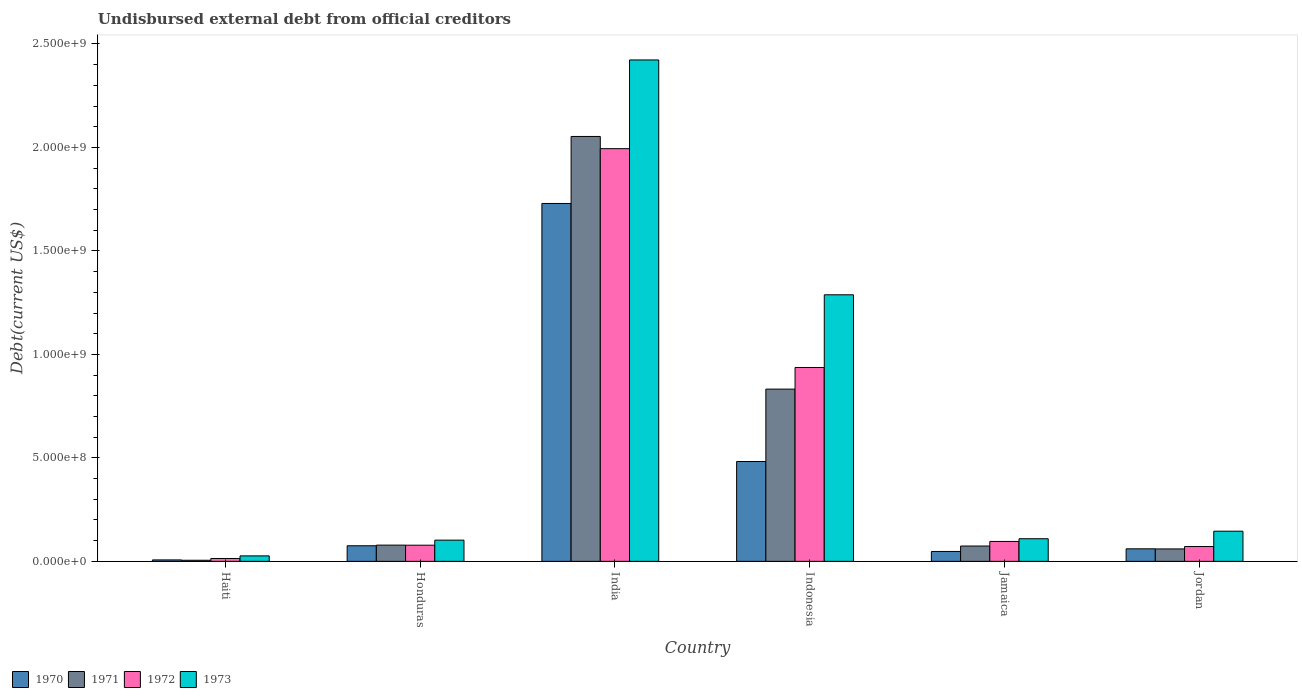Are the number of bars on each tick of the X-axis equal?
Provide a short and direct response. Yes. How many bars are there on the 1st tick from the left?
Keep it short and to the point. 4. What is the label of the 5th group of bars from the left?
Make the answer very short. Jamaica. What is the total debt in 1971 in Jordan?
Your response must be concise. 6.01e+07. Across all countries, what is the maximum total debt in 1973?
Give a very brief answer. 2.42e+09. Across all countries, what is the minimum total debt in 1970?
Make the answer very short. 6.96e+06. In which country was the total debt in 1971 minimum?
Offer a very short reply. Haiti. What is the total total debt in 1970 in the graph?
Provide a succinct answer. 2.40e+09. What is the difference between the total debt in 1970 in Honduras and that in India?
Provide a succinct answer. -1.65e+09. What is the difference between the total debt in 1972 in Haiti and the total debt in 1970 in Indonesia?
Make the answer very short. -4.69e+08. What is the average total debt in 1971 per country?
Offer a terse response. 5.17e+08. What is the difference between the total debt of/in 1971 and total debt of/in 1972 in Honduras?
Your response must be concise. 3.37e+05. What is the ratio of the total debt in 1970 in Haiti to that in Jamaica?
Your answer should be very brief. 0.15. Is the total debt in 1970 in Haiti less than that in Jamaica?
Keep it short and to the point. Yes. What is the difference between the highest and the second highest total debt in 1971?
Your response must be concise. -1.22e+09. What is the difference between the highest and the lowest total debt in 1970?
Offer a very short reply. 1.72e+09. In how many countries, is the total debt in 1971 greater than the average total debt in 1971 taken over all countries?
Keep it short and to the point. 2. Is it the case that in every country, the sum of the total debt in 1972 and total debt in 1971 is greater than the sum of total debt in 1973 and total debt in 1970?
Keep it short and to the point. No. What does the 1st bar from the right in India represents?
Your response must be concise. 1973. Is it the case that in every country, the sum of the total debt in 1972 and total debt in 1973 is greater than the total debt in 1971?
Provide a succinct answer. Yes. Are all the bars in the graph horizontal?
Give a very brief answer. No. How many countries are there in the graph?
Your answer should be compact. 6. Does the graph contain grids?
Your answer should be very brief. No. Where does the legend appear in the graph?
Give a very brief answer. Bottom left. How many legend labels are there?
Provide a succinct answer. 4. How are the legend labels stacked?
Keep it short and to the point. Horizontal. What is the title of the graph?
Your answer should be very brief. Undisbursed external debt from official creditors. What is the label or title of the X-axis?
Your response must be concise. Country. What is the label or title of the Y-axis?
Give a very brief answer. Debt(current US$). What is the Debt(current US$) in 1970 in Haiti?
Make the answer very short. 6.96e+06. What is the Debt(current US$) of 1971 in Haiti?
Keep it short and to the point. 5.35e+06. What is the Debt(current US$) in 1972 in Haiti?
Give a very brief answer. 1.39e+07. What is the Debt(current US$) of 1973 in Haiti?
Offer a terse response. 2.64e+07. What is the Debt(current US$) of 1970 in Honduras?
Your answer should be compact. 7.54e+07. What is the Debt(current US$) in 1971 in Honduras?
Your response must be concise. 7.85e+07. What is the Debt(current US$) of 1972 in Honduras?
Offer a terse response. 7.81e+07. What is the Debt(current US$) of 1973 in Honduras?
Offer a very short reply. 1.02e+08. What is the Debt(current US$) in 1970 in India?
Provide a short and direct response. 1.73e+09. What is the Debt(current US$) of 1971 in India?
Your answer should be very brief. 2.05e+09. What is the Debt(current US$) in 1972 in India?
Your response must be concise. 1.99e+09. What is the Debt(current US$) in 1973 in India?
Offer a terse response. 2.42e+09. What is the Debt(current US$) of 1970 in Indonesia?
Provide a short and direct response. 4.82e+08. What is the Debt(current US$) in 1971 in Indonesia?
Your answer should be compact. 8.32e+08. What is the Debt(current US$) of 1972 in Indonesia?
Your response must be concise. 9.37e+08. What is the Debt(current US$) of 1973 in Indonesia?
Keep it short and to the point. 1.29e+09. What is the Debt(current US$) in 1970 in Jamaica?
Your answer should be compact. 4.78e+07. What is the Debt(current US$) in 1971 in Jamaica?
Give a very brief answer. 7.41e+07. What is the Debt(current US$) of 1972 in Jamaica?
Make the answer very short. 9.62e+07. What is the Debt(current US$) of 1973 in Jamaica?
Make the answer very short. 1.09e+08. What is the Debt(current US$) of 1970 in Jordan?
Keep it short and to the point. 6.06e+07. What is the Debt(current US$) in 1971 in Jordan?
Provide a succinct answer. 6.01e+07. What is the Debt(current US$) of 1972 in Jordan?
Your answer should be compact. 7.16e+07. What is the Debt(current US$) in 1973 in Jordan?
Your response must be concise. 1.46e+08. Across all countries, what is the maximum Debt(current US$) in 1970?
Give a very brief answer. 1.73e+09. Across all countries, what is the maximum Debt(current US$) of 1971?
Give a very brief answer. 2.05e+09. Across all countries, what is the maximum Debt(current US$) in 1972?
Make the answer very short. 1.99e+09. Across all countries, what is the maximum Debt(current US$) in 1973?
Keep it short and to the point. 2.42e+09. Across all countries, what is the minimum Debt(current US$) of 1970?
Your response must be concise. 6.96e+06. Across all countries, what is the minimum Debt(current US$) of 1971?
Offer a very short reply. 5.35e+06. Across all countries, what is the minimum Debt(current US$) in 1972?
Your answer should be very brief. 1.39e+07. Across all countries, what is the minimum Debt(current US$) in 1973?
Give a very brief answer. 2.64e+07. What is the total Debt(current US$) of 1970 in the graph?
Your answer should be very brief. 2.40e+09. What is the total Debt(current US$) of 1971 in the graph?
Your answer should be compact. 3.10e+09. What is the total Debt(current US$) in 1972 in the graph?
Your answer should be very brief. 3.19e+09. What is the total Debt(current US$) in 1973 in the graph?
Your answer should be very brief. 4.09e+09. What is the difference between the Debt(current US$) of 1970 in Haiti and that in Honduras?
Ensure brevity in your answer.  -6.84e+07. What is the difference between the Debt(current US$) in 1971 in Haiti and that in Honduras?
Your answer should be compact. -7.31e+07. What is the difference between the Debt(current US$) of 1972 in Haiti and that in Honduras?
Your answer should be very brief. -6.42e+07. What is the difference between the Debt(current US$) in 1973 in Haiti and that in Honduras?
Give a very brief answer. -7.61e+07. What is the difference between the Debt(current US$) in 1970 in Haiti and that in India?
Provide a succinct answer. -1.72e+09. What is the difference between the Debt(current US$) of 1971 in Haiti and that in India?
Offer a terse response. -2.05e+09. What is the difference between the Debt(current US$) in 1972 in Haiti and that in India?
Keep it short and to the point. -1.98e+09. What is the difference between the Debt(current US$) of 1973 in Haiti and that in India?
Offer a terse response. -2.40e+09. What is the difference between the Debt(current US$) of 1970 in Haiti and that in Indonesia?
Ensure brevity in your answer.  -4.75e+08. What is the difference between the Debt(current US$) of 1971 in Haiti and that in Indonesia?
Give a very brief answer. -8.27e+08. What is the difference between the Debt(current US$) in 1972 in Haiti and that in Indonesia?
Ensure brevity in your answer.  -9.23e+08. What is the difference between the Debt(current US$) of 1973 in Haiti and that in Indonesia?
Your answer should be very brief. -1.26e+09. What is the difference between the Debt(current US$) of 1970 in Haiti and that in Jamaica?
Give a very brief answer. -4.08e+07. What is the difference between the Debt(current US$) in 1971 in Haiti and that in Jamaica?
Offer a very short reply. -6.88e+07. What is the difference between the Debt(current US$) in 1972 in Haiti and that in Jamaica?
Make the answer very short. -8.23e+07. What is the difference between the Debt(current US$) of 1973 in Haiti and that in Jamaica?
Provide a succinct answer. -8.29e+07. What is the difference between the Debt(current US$) of 1970 in Haiti and that in Jordan?
Your answer should be compact. -5.36e+07. What is the difference between the Debt(current US$) of 1971 in Haiti and that in Jordan?
Offer a very short reply. -5.47e+07. What is the difference between the Debt(current US$) in 1972 in Haiti and that in Jordan?
Provide a succinct answer. -5.77e+07. What is the difference between the Debt(current US$) of 1973 in Haiti and that in Jordan?
Provide a short and direct response. -1.19e+08. What is the difference between the Debt(current US$) of 1970 in Honduras and that in India?
Keep it short and to the point. -1.65e+09. What is the difference between the Debt(current US$) in 1971 in Honduras and that in India?
Make the answer very short. -1.97e+09. What is the difference between the Debt(current US$) in 1972 in Honduras and that in India?
Your response must be concise. -1.92e+09. What is the difference between the Debt(current US$) in 1973 in Honduras and that in India?
Keep it short and to the point. -2.32e+09. What is the difference between the Debt(current US$) in 1970 in Honduras and that in Indonesia?
Keep it short and to the point. -4.07e+08. What is the difference between the Debt(current US$) in 1971 in Honduras and that in Indonesia?
Your answer should be very brief. -7.54e+08. What is the difference between the Debt(current US$) of 1972 in Honduras and that in Indonesia?
Your response must be concise. -8.59e+08. What is the difference between the Debt(current US$) of 1973 in Honduras and that in Indonesia?
Offer a terse response. -1.19e+09. What is the difference between the Debt(current US$) in 1970 in Honduras and that in Jamaica?
Your response must be concise. 2.76e+07. What is the difference between the Debt(current US$) of 1971 in Honduras and that in Jamaica?
Give a very brief answer. 4.34e+06. What is the difference between the Debt(current US$) in 1972 in Honduras and that in Jamaica?
Offer a very short reply. -1.81e+07. What is the difference between the Debt(current US$) of 1973 in Honduras and that in Jamaica?
Ensure brevity in your answer.  -6.85e+06. What is the difference between the Debt(current US$) in 1970 in Honduras and that in Jordan?
Provide a short and direct response. 1.48e+07. What is the difference between the Debt(current US$) in 1971 in Honduras and that in Jordan?
Offer a very short reply. 1.84e+07. What is the difference between the Debt(current US$) of 1972 in Honduras and that in Jordan?
Give a very brief answer. 6.52e+06. What is the difference between the Debt(current US$) of 1973 in Honduras and that in Jordan?
Make the answer very short. -4.32e+07. What is the difference between the Debt(current US$) of 1970 in India and that in Indonesia?
Give a very brief answer. 1.25e+09. What is the difference between the Debt(current US$) in 1971 in India and that in Indonesia?
Keep it short and to the point. 1.22e+09. What is the difference between the Debt(current US$) of 1972 in India and that in Indonesia?
Offer a terse response. 1.06e+09. What is the difference between the Debt(current US$) in 1973 in India and that in Indonesia?
Your answer should be compact. 1.13e+09. What is the difference between the Debt(current US$) of 1970 in India and that in Jamaica?
Provide a short and direct response. 1.68e+09. What is the difference between the Debt(current US$) of 1971 in India and that in Jamaica?
Offer a very short reply. 1.98e+09. What is the difference between the Debt(current US$) of 1972 in India and that in Jamaica?
Make the answer very short. 1.90e+09. What is the difference between the Debt(current US$) of 1973 in India and that in Jamaica?
Your answer should be compact. 2.31e+09. What is the difference between the Debt(current US$) of 1970 in India and that in Jordan?
Ensure brevity in your answer.  1.67e+09. What is the difference between the Debt(current US$) in 1971 in India and that in Jordan?
Your answer should be very brief. 1.99e+09. What is the difference between the Debt(current US$) in 1972 in India and that in Jordan?
Offer a very short reply. 1.92e+09. What is the difference between the Debt(current US$) of 1973 in India and that in Jordan?
Give a very brief answer. 2.28e+09. What is the difference between the Debt(current US$) in 1970 in Indonesia and that in Jamaica?
Offer a terse response. 4.35e+08. What is the difference between the Debt(current US$) of 1971 in Indonesia and that in Jamaica?
Make the answer very short. 7.58e+08. What is the difference between the Debt(current US$) of 1972 in Indonesia and that in Jamaica?
Ensure brevity in your answer.  8.41e+08. What is the difference between the Debt(current US$) in 1973 in Indonesia and that in Jamaica?
Ensure brevity in your answer.  1.18e+09. What is the difference between the Debt(current US$) in 1970 in Indonesia and that in Jordan?
Keep it short and to the point. 4.22e+08. What is the difference between the Debt(current US$) in 1971 in Indonesia and that in Jordan?
Your answer should be very brief. 7.72e+08. What is the difference between the Debt(current US$) of 1972 in Indonesia and that in Jordan?
Your response must be concise. 8.65e+08. What is the difference between the Debt(current US$) in 1973 in Indonesia and that in Jordan?
Offer a very short reply. 1.14e+09. What is the difference between the Debt(current US$) in 1970 in Jamaica and that in Jordan?
Give a very brief answer. -1.28e+07. What is the difference between the Debt(current US$) of 1971 in Jamaica and that in Jordan?
Give a very brief answer. 1.40e+07. What is the difference between the Debt(current US$) in 1972 in Jamaica and that in Jordan?
Provide a short and direct response. 2.46e+07. What is the difference between the Debt(current US$) of 1973 in Jamaica and that in Jordan?
Provide a short and direct response. -3.64e+07. What is the difference between the Debt(current US$) in 1970 in Haiti and the Debt(current US$) in 1971 in Honduras?
Keep it short and to the point. -7.15e+07. What is the difference between the Debt(current US$) of 1970 in Haiti and the Debt(current US$) of 1972 in Honduras?
Make the answer very short. -7.12e+07. What is the difference between the Debt(current US$) in 1970 in Haiti and the Debt(current US$) in 1973 in Honduras?
Offer a very short reply. -9.55e+07. What is the difference between the Debt(current US$) of 1971 in Haiti and the Debt(current US$) of 1972 in Honduras?
Make the answer very short. -7.28e+07. What is the difference between the Debt(current US$) of 1971 in Haiti and the Debt(current US$) of 1973 in Honduras?
Offer a terse response. -9.71e+07. What is the difference between the Debt(current US$) of 1972 in Haiti and the Debt(current US$) of 1973 in Honduras?
Provide a succinct answer. -8.86e+07. What is the difference between the Debt(current US$) of 1970 in Haiti and the Debt(current US$) of 1971 in India?
Keep it short and to the point. -2.05e+09. What is the difference between the Debt(current US$) of 1970 in Haiti and the Debt(current US$) of 1972 in India?
Keep it short and to the point. -1.99e+09. What is the difference between the Debt(current US$) in 1970 in Haiti and the Debt(current US$) in 1973 in India?
Offer a terse response. -2.42e+09. What is the difference between the Debt(current US$) in 1971 in Haiti and the Debt(current US$) in 1972 in India?
Keep it short and to the point. -1.99e+09. What is the difference between the Debt(current US$) in 1971 in Haiti and the Debt(current US$) in 1973 in India?
Make the answer very short. -2.42e+09. What is the difference between the Debt(current US$) in 1972 in Haiti and the Debt(current US$) in 1973 in India?
Give a very brief answer. -2.41e+09. What is the difference between the Debt(current US$) in 1970 in Haiti and the Debt(current US$) in 1971 in Indonesia?
Provide a succinct answer. -8.25e+08. What is the difference between the Debt(current US$) of 1970 in Haiti and the Debt(current US$) of 1972 in Indonesia?
Provide a short and direct response. -9.30e+08. What is the difference between the Debt(current US$) in 1970 in Haiti and the Debt(current US$) in 1973 in Indonesia?
Offer a terse response. -1.28e+09. What is the difference between the Debt(current US$) of 1971 in Haiti and the Debt(current US$) of 1972 in Indonesia?
Make the answer very short. -9.31e+08. What is the difference between the Debt(current US$) in 1971 in Haiti and the Debt(current US$) in 1973 in Indonesia?
Make the answer very short. -1.28e+09. What is the difference between the Debt(current US$) of 1972 in Haiti and the Debt(current US$) of 1973 in Indonesia?
Provide a short and direct response. -1.27e+09. What is the difference between the Debt(current US$) of 1970 in Haiti and the Debt(current US$) of 1971 in Jamaica?
Provide a short and direct response. -6.72e+07. What is the difference between the Debt(current US$) in 1970 in Haiti and the Debt(current US$) in 1972 in Jamaica?
Your response must be concise. -8.92e+07. What is the difference between the Debt(current US$) of 1970 in Haiti and the Debt(current US$) of 1973 in Jamaica?
Offer a very short reply. -1.02e+08. What is the difference between the Debt(current US$) in 1971 in Haiti and the Debt(current US$) in 1972 in Jamaica?
Your answer should be very brief. -9.08e+07. What is the difference between the Debt(current US$) in 1971 in Haiti and the Debt(current US$) in 1973 in Jamaica?
Provide a succinct answer. -1.04e+08. What is the difference between the Debt(current US$) in 1972 in Haiti and the Debt(current US$) in 1973 in Jamaica?
Your response must be concise. -9.55e+07. What is the difference between the Debt(current US$) of 1970 in Haiti and the Debt(current US$) of 1971 in Jordan?
Give a very brief answer. -5.31e+07. What is the difference between the Debt(current US$) of 1970 in Haiti and the Debt(current US$) of 1972 in Jordan?
Your response must be concise. -6.46e+07. What is the difference between the Debt(current US$) of 1970 in Haiti and the Debt(current US$) of 1973 in Jordan?
Offer a very short reply. -1.39e+08. What is the difference between the Debt(current US$) of 1971 in Haiti and the Debt(current US$) of 1972 in Jordan?
Provide a succinct answer. -6.63e+07. What is the difference between the Debt(current US$) of 1971 in Haiti and the Debt(current US$) of 1973 in Jordan?
Offer a very short reply. -1.40e+08. What is the difference between the Debt(current US$) in 1972 in Haiti and the Debt(current US$) in 1973 in Jordan?
Provide a succinct answer. -1.32e+08. What is the difference between the Debt(current US$) of 1970 in Honduras and the Debt(current US$) of 1971 in India?
Give a very brief answer. -1.98e+09. What is the difference between the Debt(current US$) in 1970 in Honduras and the Debt(current US$) in 1972 in India?
Offer a terse response. -1.92e+09. What is the difference between the Debt(current US$) in 1970 in Honduras and the Debt(current US$) in 1973 in India?
Give a very brief answer. -2.35e+09. What is the difference between the Debt(current US$) of 1971 in Honduras and the Debt(current US$) of 1972 in India?
Provide a succinct answer. -1.92e+09. What is the difference between the Debt(current US$) of 1971 in Honduras and the Debt(current US$) of 1973 in India?
Keep it short and to the point. -2.34e+09. What is the difference between the Debt(current US$) in 1972 in Honduras and the Debt(current US$) in 1973 in India?
Offer a terse response. -2.34e+09. What is the difference between the Debt(current US$) of 1970 in Honduras and the Debt(current US$) of 1971 in Indonesia?
Your response must be concise. -7.57e+08. What is the difference between the Debt(current US$) of 1970 in Honduras and the Debt(current US$) of 1972 in Indonesia?
Provide a succinct answer. -8.61e+08. What is the difference between the Debt(current US$) of 1970 in Honduras and the Debt(current US$) of 1973 in Indonesia?
Your response must be concise. -1.21e+09. What is the difference between the Debt(current US$) in 1971 in Honduras and the Debt(current US$) in 1972 in Indonesia?
Provide a succinct answer. -8.58e+08. What is the difference between the Debt(current US$) in 1971 in Honduras and the Debt(current US$) in 1973 in Indonesia?
Keep it short and to the point. -1.21e+09. What is the difference between the Debt(current US$) in 1972 in Honduras and the Debt(current US$) in 1973 in Indonesia?
Provide a succinct answer. -1.21e+09. What is the difference between the Debt(current US$) of 1970 in Honduras and the Debt(current US$) of 1971 in Jamaica?
Your answer should be compact. 1.28e+06. What is the difference between the Debt(current US$) of 1970 in Honduras and the Debt(current US$) of 1972 in Jamaica?
Ensure brevity in your answer.  -2.08e+07. What is the difference between the Debt(current US$) in 1970 in Honduras and the Debt(current US$) in 1973 in Jamaica?
Provide a succinct answer. -3.39e+07. What is the difference between the Debt(current US$) of 1971 in Honduras and the Debt(current US$) of 1972 in Jamaica?
Offer a very short reply. -1.77e+07. What is the difference between the Debt(current US$) in 1971 in Honduras and the Debt(current US$) in 1973 in Jamaica?
Ensure brevity in your answer.  -3.09e+07. What is the difference between the Debt(current US$) of 1972 in Honduras and the Debt(current US$) of 1973 in Jamaica?
Your answer should be compact. -3.12e+07. What is the difference between the Debt(current US$) of 1970 in Honduras and the Debt(current US$) of 1971 in Jordan?
Keep it short and to the point. 1.53e+07. What is the difference between the Debt(current US$) in 1970 in Honduras and the Debt(current US$) in 1972 in Jordan?
Provide a short and direct response. 3.79e+06. What is the difference between the Debt(current US$) in 1970 in Honduras and the Debt(current US$) in 1973 in Jordan?
Keep it short and to the point. -7.03e+07. What is the difference between the Debt(current US$) of 1971 in Honduras and the Debt(current US$) of 1972 in Jordan?
Keep it short and to the point. 6.85e+06. What is the difference between the Debt(current US$) of 1971 in Honduras and the Debt(current US$) of 1973 in Jordan?
Offer a very short reply. -6.73e+07. What is the difference between the Debt(current US$) in 1972 in Honduras and the Debt(current US$) in 1973 in Jordan?
Make the answer very short. -6.76e+07. What is the difference between the Debt(current US$) in 1970 in India and the Debt(current US$) in 1971 in Indonesia?
Provide a short and direct response. 8.97e+08. What is the difference between the Debt(current US$) of 1970 in India and the Debt(current US$) of 1972 in Indonesia?
Your answer should be compact. 7.93e+08. What is the difference between the Debt(current US$) in 1970 in India and the Debt(current US$) in 1973 in Indonesia?
Your answer should be compact. 4.41e+08. What is the difference between the Debt(current US$) of 1971 in India and the Debt(current US$) of 1972 in Indonesia?
Offer a very short reply. 1.12e+09. What is the difference between the Debt(current US$) of 1971 in India and the Debt(current US$) of 1973 in Indonesia?
Make the answer very short. 7.65e+08. What is the difference between the Debt(current US$) of 1972 in India and the Debt(current US$) of 1973 in Indonesia?
Make the answer very short. 7.06e+08. What is the difference between the Debt(current US$) of 1970 in India and the Debt(current US$) of 1971 in Jamaica?
Ensure brevity in your answer.  1.66e+09. What is the difference between the Debt(current US$) in 1970 in India and the Debt(current US$) in 1972 in Jamaica?
Offer a terse response. 1.63e+09. What is the difference between the Debt(current US$) of 1970 in India and the Debt(current US$) of 1973 in Jamaica?
Keep it short and to the point. 1.62e+09. What is the difference between the Debt(current US$) of 1971 in India and the Debt(current US$) of 1972 in Jamaica?
Offer a very short reply. 1.96e+09. What is the difference between the Debt(current US$) in 1971 in India and the Debt(current US$) in 1973 in Jamaica?
Your response must be concise. 1.94e+09. What is the difference between the Debt(current US$) of 1972 in India and the Debt(current US$) of 1973 in Jamaica?
Ensure brevity in your answer.  1.88e+09. What is the difference between the Debt(current US$) of 1970 in India and the Debt(current US$) of 1971 in Jordan?
Your answer should be very brief. 1.67e+09. What is the difference between the Debt(current US$) of 1970 in India and the Debt(current US$) of 1972 in Jordan?
Offer a very short reply. 1.66e+09. What is the difference between the Debt(current US$) of 1970 in India and the Debt(current US$) of 1973 in Jordan?
Your response must be concise. 1.58e+09. What is the difference between the Debt(current US$) in 1971 in India and the Debt(current US$) in 1972 in Jordan?
Keep it short and to the point. 1.98e+09. What is the difference between the Debt(current US$) in 1971 in India and the Debt(current US$) in 1973 in Jordan?
Provide a succinct answer. 1.91e+09. What is the difference between the Debt(current US$) of 1972 in India and the Debt(current US$) of 1973 in Jordan?
Your response must be concise. 1.85e+09. What is the difference between the Debt(current US$) in 1970 in Indonesia and the Debt(current US$) in 1971 in Jamaica?
Your response must be concise. 4.08e+08. What is the difference between the Debt(current US$) in 1970 in Indonesia and the Debt(current US$) in 1972 in Jamaica?
Your answer should be very brief. 3.86e+08. What is the difference between the Debt(current US$) in 1970 in Indonesia and the Debt(current US$) in 1973 in Jamaica?
Your answer should be very brief. 3.73e+08. What is the difference between the Debt(current US$) of 1971 in Indonesia and the Debt(current US$) of 1972 in Jamaica?
Make the answer very short. 7.36e+08. What is the difference between the Debt(current US$) in 1971 in Indonesia and the Debt(current US$) in 1973 in Jamaica?
Offer a very short reply. 7.23e+08. What is the difference between the Debt(current US$) of 1972 in Indonesia and the Debt(current US$) of 1973 in Jamaica?
Your answer should be compact. 8.27e+08. What is the difference between the Debt(current US$) in 1970 in Indonesia and the Debt(current US$) in 1971 in Jordan?
Ensure brevity in your answer.  4.22e+08. What is the difference between the Debt(current US$) in 1970 in Indonesia and the Debt(current US$) in 1972 in Jordan?
Your answer should be very brief. 4.11e+08. What is the difference between the Debt(current US$) in 1970 in Indonesia and the Debt(current US$) in 1973 in Jordan?
Make the answer very short. 3.37e+08. What is the difference between the Debt(current US$) of 1971 in Indonesia and the Debt(current US$) of 1972 in Jordan?
Keep it short and to the point. 7.61e+08. What is the difference between the Debt(current US$) in 1971 in Indonesia and the Debt(current US$) in 1973 in Jordan?
Your answer should be very brief. 6.87e+08. What is the difference between the Debt(current US$) in 1972 in Indonesia and the Debt(current US$) in 1973 in Jordan?
Make the answer very short. 7.91e+08. What is the difference between the Debt(current US$) in 1970 in Jamaica and the Debt(current US$) in 1971 in Jordan?
Ensure brevity in your answer.  -1.23e+07. What is the difference between the Debt(current US$) of 1970 in Jamaica and the Debt(current US$) of 1972 in Jordan?
Offer a terse response. -2.38e+07. What is the difference between the Debt(current US$) of 1970 in Jamaica and the Debt(current US$) of 1973 in Jordan?
Offer a terse response. -9.79e+07. What is the difference between the Debt(current US$) of 1971 in Jamaica and the Debt(current US$) of 1972 in Jordan?
Your response must be concise. 2.51e+06. What is the difference between the Debt(current US$) of 1971 in Jamaica and the Debt(current US$) of 1973 in Jordan?
Provide a short and direct response. -7.16e+07. What is the difference between the Debt(current US$) in 1972 in Jamaica and the Debt(current US$) in 1973 in Jordan?
Give a very brief answer. -4.95e+07. What is the average Debt(current US$) in 1970 per country?
Provide a short and direct response. 4.00e+08. What is the average Debt(current US$) of 1971 per country?
Ensure brevity in your answer.  5.17e+08. What is the average Debt(current US$) in 1972 per country?
Ensure brevity in your answer.  5.32e+08. What is the average Debt(current US$) of 1973 per country?
Ensure brevity in your answer.  6.82e+08. What is the difference between the Debt(current US$) of 1970 and Debt(current US$) of 1971 in Haiti?
Ensure brevity in your answer.  1.61e+06. What is the difference between the Debt(current US$) of 1970 and Debt(current US$) of 1972 in Haiti?
Provide a short and direct response. -6.92e+06. What is the difference between the Debt(current US$) of 1970 and Debt(current US$) of 1973 in Haiti?
Provide a succinct answer. -1.95e+07. What is the difference between the Debt(current US$) in 1971 and Debt(current US$) in 1972 in Haiti?
Offer a very short reply. -8.53e+06. What is the difference between the Debt(current US$) of 1971 and Debt(current US$) of 1973 in Haiti?
Provide a short and direct response. -2.11e+07. What is the difference between the Debt(current US$) of 1972 and Debt(current US$) of 1973 in Haiti?
Offer a terse response. -1.25e+07. What is the difference between the Debt(current US$) of 1970 and Debt(current US$) of 1971 in Honduras?
Ensure brevity in your answer.  -3.06e+06. What is the difference between the Debt(current US$) of 1970 and Debt(current US$) of 1972 in Honduras?
Provide a succinct answer. -2.72e+06. What is the difference between the Debt(current US$) in 1970 and Debt(current US$) in 1973 in Honduras?
Make the answer very short. -2.71e+07. What is the difference between the Debt(current US$) in 1971 and Debt(current US$) in 1972 in Honduras?
Offer a terse response. 3.37e+05. What is the difference between the Debt(current US$) of 1971 and Debt(current US$) of 1973 in Honduras?
Give a very brief answer. -2.40e+07. What is the difference between the Debt(current US$) of 1972 and Debt(current US$) of 1973 in Honduras?
Provide a short and direct response. -2.44e+07. What is the difference between the Debt(current US$) in 1970 and Debt(current US$) in 1971 in India?
Your answer should be very brief. -3.24e+08. What is the difference between the Debt(current US$) of 1970 and Debt(current US$) of 1972 in India?
Offer a very short reply. -2.65e+08. What is the difference between the Debt(current US$) of 1970 and Debt(current US$) of 1973 in India?
Your answer should be very brief. -6.94e+08. What is the difference between the Debt(current US$) of 1971 and Debt(current US$) of 1972 in India?
Provide a succinct answer. 5.89e+07. What is the difference between the Debt(current US$) in 1971 and Debt(current US$) in 1973 in India?
Your answer should be compact. -3.70e+08. What is the difference between the Debt(current US$) in 1972 and Debt(current US$) in 1973 in India?
Keep it short and to the point. -4.29e+08. What is the difference between the Debt(current US$) in 1970 and Debt(current US$) in 1971 in Indonesia?
Keep it short and to the point. -3.50e+08. What is the difference between the Debt(current US$) of 1970 and Debt(current US$) of 1972 in Indonesia?
Give a very brief answer. -4.54e+08. What is the difference between the Debt(current US$) of 1970 and Debt(current US$) of 1973 in Indonesia?
Offer a terse response. -8.06e+08. What is the difference between the Debt(current US$) of 1971 and Debt(current US$) of 1972 in Indonesia?
Your response must be concise. -1.05e+08. What is the difference between the Debt(current US$) in 1971 and Debt(current US$) in 1973 in Indonesia?
Make the answer very short. -4.56e+08. What is the difference between the Debt(current US$) in 1972 and Debt(current US$) in 1973 in Indonesia?
Offer a terse response. -3.51e+08. What is the difference between the Debt(current US$) of 1970 and Debt(current US$) of 1971 in Jamaica?
Your answer should be very brief. -2.63e+07. What is the difference between the Debt(current US$) of 1970 and Debt(current US$) of 1972 in Jamaica?
Your answer should be very brief. -4.84e+07. What is the difference between the Debt(current US$) in 1970 and Debt(current US$) in 1973 in Jamaica?
Offer a terse response. -6.15e+07. What is the difference between the Debt(current US$) in 1971 and Debt(current US$) in 1972 in Jamaica?
Ensure brevity in your answer.  -2.21e+07. What is the difference between the Debt(current US$) of 1971 and Debt(current US$) of 1973 in Jamaica?
Your response must be concise. -3.52e+07. What is the difference between the Debt(current US$) of 1972 and Debt(current US$) of 1973 in Jamaica?
Ensure brevity in your answer.  -1.32e+07. What is the difference between the Debt(current US$) of 1970 and Debt(current US$) of 1971 in Jordan?
Give a very brief answer. 5.19e+05. What is the difference between the Debt(current US$) of 1970 and Debt(current US$) of 1972 in Jordan?
Provide a succinct answer. -1.10e+07. What is the difference between the Debt(current US$) in 1970 and Debt(current US$) in 1973 in Jordan?
Offer a terse response. -8.51e+07. What is the difference between the Debt(current US$) in 1971 and Debt(current US$) in 1972 in Jordan?
Your response must be concise. -1.15e+07. What is the difference between the Debt(current US$) of 1971 and Debt(current US$) of 1973 in Jordan?
Keep it short and to the point. -8.57e+07. What is the difference between the Debt(current US$) in 1972 and Debt(current US$) in 1973 in Jordan?
Keep it short and to the point. -7.41e+07. What is the ratio of the Debt(current US$) of 1970 in Haiti to that in Honduras?
Offer a terse response. 0.09. What is the ratio of the Debt(current US$) in 1971 in Haiti to that in Honduras?
Provide a succinct answer. 0.07. What is the ratio of the Debt(current US$) in 1972 in Haiti to that in Honduras?
Give a very brief answer. 0.18. What is the ratio of the Debt(current US$) of 1973 in Haiti to that in Honduras?
Provide a succinct answer. 0.26. What is the ratio of the Debt(current US$) in 1970 in Haiti to that in India?
Ensure brevity in your answer.  0. What is the ratio of the Debt(current US$) of 1971 in Haiti to that in India?
Make the answer very short. 0. What is the ratio of the Debt(current US$) in 1972 in Haiti to that in India?
Provide a short and direct response. 0.01. What is the ratio of the Debt(current US$) in 1973 in Haiti to that in India?
Make the answer very short. 0.01. What is the ratio of the Debt(current US$) of 1970 in Haiti to that in Indonesia?
Provide a succinct answer. 0.01. What is the ratio of the Debt(current US$) in 1971 in Haiti to that in Indonesia?
Ensure brevity in your answer.  0.01. What is the ratio of the Debt(current US$) of 1972 in Haiti to that in Indonesia?
Provide a succinct answer. 0.01. What is the ratio of the Debt(current US$) in 1973 in Haiti to that in Indonesia?
Offer a very short reply. 0.02. What is the ratio of the Debt(current US$) in 1970 in Haiti to that in Jamaica?
Your answer should be very brief. 0.15. What is the ratio of the Debt(current US$) in 1971 in Haiti to that in Jamaica?
Keep it short and to the point. 0.07. What is the ratio of the Debt(current US$) in 1972 in Haiti to that in Jamaica?
Your answer should be very brief. 0.14. What is the ratio of the Debt(current US$) in 1973 in Haiti to that in Jamaica?
Your response must be concise. 0.24. What is the ratio of the Debt(current US$) of 1970 in Haiti to that in Jordan?
Your answer should be very brief. 0.11. What is the ratio of the Debt(current US$) of 1971 in Haiti to that in Jordan?
Your answer should be compact. 0.09. What is the ratio of the Debt(current US$) in 1972 in Haiti to that in Jordan?
Provide a short and direct response. 0.19. What is the ratio of the Debt(current US$) in 1973 in Haiti to that in Jordan?
Your answer should be very brief. 0.18. What is the ratio of the Debt(current US$) of 1970 in Honduras to that in India?
Your answer should be very brief. 0.04. What is the ratio of the Debt(current US$) of 1971 in Honduras to that in India?
Offer a terse response. 0.04. What is the ratio of the Debt(current US$) of 1972 in Honduras to that in India?
Offer a very short reply. 0.04. What is the ratio of the Debt(current US$) of 1973 in Honduras to that in India?
Give a very brief answer. 0.04. What is the ratio of the Debt(current US$) in 1970 in Honduras to that in Indonesia?
Provide a succinct answer. 0.16. What is the ratio of the Debt(current US$) in 1971 in Honduras to that in Indonesia?
Offer a terse response. 0.09. What is the ratio of the Debt(current US$) of 1972 in Honduras to that in Indonesia?
Make the answer very short. 0.08. What is the ratio of the Debt(current US$) in 1973 in Honduras to that in Indonesia?
Offer a terse response. 0.08. What is the ratio of the Debt(current US$) in 1970 in Honduras to that in Jamaica?
Your answer should be very brief. 1.58. What is the ratio of the Debt(current US$) in 1971 in Honduras to that in Jamaica?
Ensure brevity in your answer.  1.06. What is the ratio of the Debt(current US$) in 1972 in Honduras to that in Jamaica?
Offer a very short reply. 0.81. What is the ratio of the Debt(current US$) of 1973 in Honduras to that in Jamaica?
Your response must be concise. 0.94. What is the ratio of the Debt(current US$) in 1970 in Honduras to that in Jordan?
Offer a terse response. 1.24. What is the ratio of the Debt(current US$) in 1971 in Honduras to that in Jordan?
Your answer should be very brief. 1.31. What is the ratio of the Debt(current US$) in 1972 in Honduras to that in Jordan?
Your answer should be compact. 1.09. What is the ratio of the Debt(current US$) in 1973 in Honduras to that in Jordan?
Give a very brief answer. 0.7. What is the ratio of the Debt(current US$) in 1970 in India to that in Indonesia?
Offer a very short reply. 3.58. What is the ratio of the Debt(current US$) in 1971 in India to that in Indonesia?
Your answer should be compact. 2.47. What is the ratio of the Debt(current US$) of 1972 in India to that in Indonesia?
Provide a short and direct response. 2.13. What is the ratio of the Debt(current US$) in 1973 in India to that in Indonesia?
Provide a succinct answer. 1.88. What is the ratio of the Debt(current US$) in 1970 in India to that in Jamaica?
Ensure brevity in your answer.  36.18. What is the ratio of the Debt(current US$) in 1971 in India to that in Jamaica?
Provide a succinct answer. 27.7. What is the ratio of the Debt(current US$) of 1972 in India to that in Jamaica?
Make the answer very short. 20.73. What is the ratio of the Debt(current US$) of 1973 in India to that in Jamaica?
Your response must be concise. 22.16. What is the ratio of the Debt(current US$) of 1970 in India to that in Jordan?
Your response must be concise. 28.54. What is the ratio of the Debt(current US$) in 1971 in India to that in Jordan?
Make the answer very short. 34.18. What is the ratio of the Debt(current US$) in 1972 in India to that in Jordan?
Your answer should be very brief. 27.85. What is the ratio of the Debt(current US$) of 1973 in India to that in Jordan?
Give a very brief answer. 16.62. What is the ratio of the Debt(current US$) in 1970 in Indonesia to that in Jamaica?
Your response must be concise. 10.09. What is the ratio of the Debt(current US$) in 1971 in Indonesia to that in Jamaica?
Provide a short and direct response. 11.23. What is the ratio of the Debt(current US$) of 1972 in Indonesia to that in Jamaica?
Give a very brief answer. 9.74. What is the ratio of the Debt(current US$) of 1973 in Indonesia to that in Jamaica?
Offer a very short reply. 11.78. What is the ratio of the Debt(current US$) in 1970 in Indonesia to that in Jordan?
Provide a succinct answer. 7.96. What is the ratio of the Debt(current US$) of 1971 in Indonesia to that in Jordan?
Your answer should be very brief. 13.85. What is the ratio of the Debt(current US$) of 1972 in Indonesia to that in Jordan?
Provide a succinct answer. 13.08. What is the ratio of the Debt(current US$) in 1973 in Indonesia to that in Jordan?
Your answer should be compact. 8.84. What is the ratio of the Debt(current US$) of 1970 in Jamaica to that in Jordan?
Provide a succinct answer. 0.79. What is the ratio of the Debt(current US$) in 1971 in Jamaica to that in Jordan?
Ensure brevity in your answer.  1.23. What is the ratio of the Debt(current US$) of 1972 in Jamaica to that in Jordan?
Provide a short and direct response. 1.34. What is the ratio of the Debt(current US$) in 1973 in Jamaica to that in Jordan?
Ensure brevity in your answer.  0.75. What is the difference between the highest and the second highest Debt(current US$) in 1970?
Your answer should be very brief. 1.25e+09. What is the difference between the highest and the second highest Debt(current US$) of 1971?
Give a very brief answer. 1.22e+09. What is the difference between the highest and the second highest Debt(current US$) in 1972?
Give a very brief answer. 1.06e+09. What is the difference between the highest and the second highest Debt(current US$) in 1973?
Keep it short and to the point. 1.13e+09. What is the difference between the highest and the lowest Debt(current US$) of 1970?
Offer a terse response. 1.72e+09. What is the difference between the highest and the lowest Debt(current US$) of 1971?
Your response must be concise. 2.05e+09. What is the difference between the highest and the lowest Debt(current US$) of 1972?
Provide a succinct answer. 1.98e+09. What is the difference between the highest and the lowest Debt(current US$) of 1973?
Provide a short and direct response. 2.40e+09. 